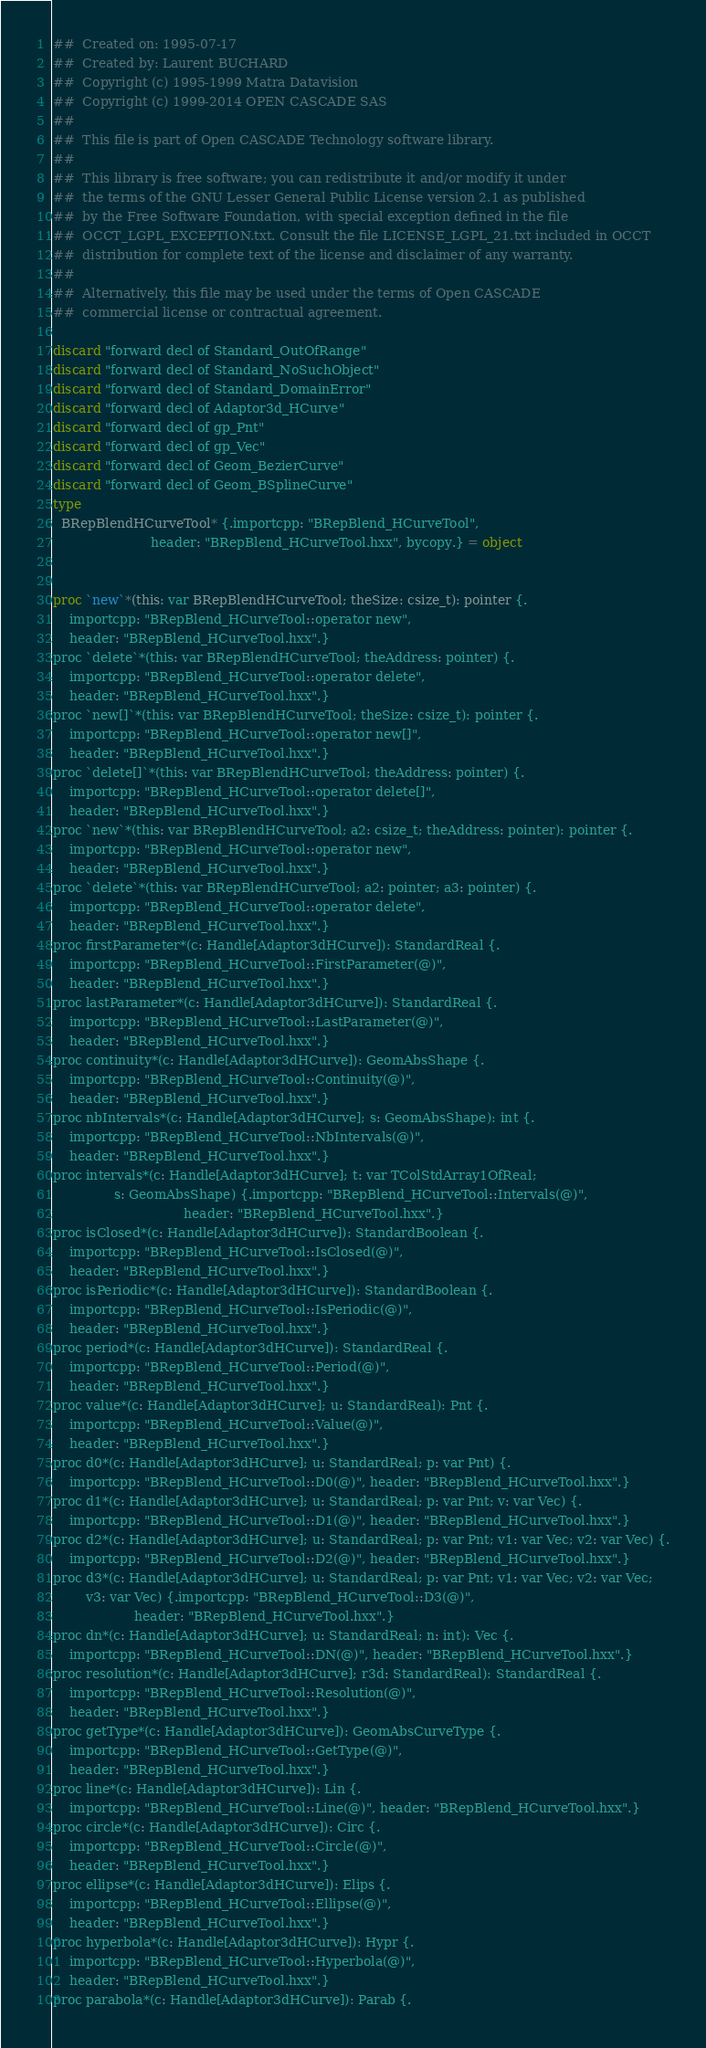<code> <loc_0><loc_0><loc_500><loc_500><_Nim_>##  Created on: 1995-07-17
##  Created by: Laurent BUCHARD
##  Copyright (c) 1995-1999 Matra Datavision
##  Copyright (c) 1999-2014 OPEN CASCADE SAS
##
##  This file is part of Open CASCADE Technology software library.
##
##  This library is free software; you can redistribute it and/or modify it under
##  the terms of the GNU Lesser General Public License version 2.1 as published
##  by the Free Software Foundation, with special exception defined in the file
##  OCCT_LGPL_EXCEPTION.txt. Consult the file LICENSE_LGPL_21.txt included in OCCT
##  distribution for complete text of the license and disclaimer of any warranty.
##
##  Alternatively, this file may be used under the terms of Open CASCADE
##  commercial license or contractual agreement.

discard "forward decl of Standard_OutOfRange"
discard "forward decl of Standard_NoSuchObject"
discard "forward decl of Standard_DomainError"
discard "forward decl of Adaptor3d_HCurve"
discard "forward decl of gp_Pnt"
discard "forward decl of gp_Vec"
discard "forward decl of Geom_BezierCurve"
discard "forward decl of Geom_BSplineCurve"
type
  BRepBlendHCurveTool* {.importcpp: "BRepBlend_HCurveTool",
                        header: "BRepBlend_HCurveTool.hxx", bycopy.} = object


proc `new`*(this: var BRepBlendHCurveTool; theSize: csize_t): pointer {.
    importcpp: "BRepBlend_HCurveTool::operator new",
    header: "BRepBlend_HCurveTool.hxx".}
proc `delete`*(this: var BRepBlendHCurveTool; theAddress: pointer) {.
    importcpp: "BRepBlend_HCurveTool::operator delete",
    header: "BRepBlend_HCurveTool.hxx".}
proc `new[]`*(this: var BRepBlendHCurveTool; theSize: csize_t): pointer {.
    importcpp: "BRepBlend_HCurveTool::operator new[]",
    header: "BRepBlend_HCurveTool.hxx".}
proc `delete[]`*(this: var BRepBlendHCurveTool; theAddress: pointer) {.
    importcpp: "BRepBlend_HCurveTool::operator delete[]",
    header: "BRepBlend_HCurveTool.hxx".}
proc `new`*(this: var BRepBlendHCurveTool; a2: csize_t; theAddress: pointer): pointer {.
    importcpp: "BRepBlend_HCurveTool::operator new",
    header: "BRepBlend_HCurveTool.hxx".}
proc `delete`*(this: var BRepBlendHCurveTool; a2: pointer; a3: pointer) {.
    importcpp: "BRepBlend_HCurveTool::operator delete",
    header: "BRepBlend_HCurveTool.hxx".}
proc firstParameter*(c: Handle[Adaptor3dHCurve]): StandardReal {.
    importcpp: "BRepBlend_HCurveTool::FirstParameter(@)",
    header: "BRepBlend_HCurveTool.hxx".}
proc lastParameter*(c: Handle[Adaptor3dHCurve]): StandardReal {.
    importcpp: "BRepBlend_HCurveTool::LastParameter(@)",
    header: "BRepBlend_HCurveTool.hxx".}
proc continuity*(c: Handle[Adaptor3dHCurve]): GeomAbsShape {.
    importcpp: "BRepBlend_HCurveTool::Continuity(@)",
    header: "BRepBlend_HCurveTool.hxx".}
proc nbIntervals*(c: Handle[Adaptor3dHCurve]; s: GeomAbsShape): int {.
    importcpp: "BRepBlend_HCurveTool::NbIntervals(@)",
    header: "BRepBlend_HCurveTool.hxx".}
proc intervals*(c: Handle[Adaptor3dHCurve]; t: var TColStdArray1OfReal;
               s: GeomAbsShape) {.importcpp: "BRepBlend_HCurveTool::Intervals(@)",
                                header: "BRepBlend_HCurveTool.hxx".}
proc isClosed*(c: Handle[Adaptor3dHCurve]): StandardBoolean {.
    importcpp: "BRepBlend_HCurveTool::IsClosed(@)",
    header: "BRepBlend_HCurveTool.hxx".}
proc isPeriodic*(c: Handle[Adaptor3dHCurve]): StandardBoolean {.
    importcpp: "BRepBlend_HCurveTool::IsPeriodic(@)",
    header: "BRepBlend_HCurveTool.hxx".}
proc period*(c: Handle[Adaptor3dHCurve]): StandardReal {.
    importcpp: "BRepBlend_HCurveTool::Period(@)",
    header: "BRepBlend_HCurveTool.hxx".}
proc value*(c: Handle[Adaptor3dHCurve]; u: StandardReal): Pnt {.
    importcpp: "BRepBlend_HCurveTool::Value(@)",
    header: "BRepBlend_HCurveTool.hxx".}
proc d0*(c: Handle[Adaptor3dHCurve]; u: StandardReal; p: var Pnt) {.
    importcpp: "BRepBlend_HCurveTool::D0(@)", header: "BRepBlend_HCurveTool.hxx".}
proc d1*(c: Handle[Adaptor3dHCurve]; u: StandardReal; p: var Pnt; v: var Vec) {.
    importcpp: "BRepBlend_HCurveTool::D1(@)", header: "BRepBlend_HCurveTool.hxx".}
proc d2*(c: Handle[Adaptor3dHCurve]; u: StandardReal; p: var Pnt; v1: var Vec; v2: var Vec) {.
    importcpp: "BRepBlend_HCurveTool::D2(@)", header: "BRepBlend_HCurveTool.hxx".}
proc d3*(c: Handle[Adaptor3dHCurve]; u: StandardReal; p: var Pnt; v1: var Vec; v2: var Vec;
        v3: var Vec) {.importcpp: "BRepBlend_HCurveTool::D3(@)",
                    header: "BRepBlend_HCurveTool.hxx".}
proc dn*(c: Handle[Adaptor3dHCurve]; u: StandardReal; n: int): Vec {.
    importcpp: "BRepBlend_HCurveTool::DN(@)", header: "BRepBlend_HCurveTool.hxx".}
proc resolution*(c: Handle[Adaptor3dHCurve]; r3d: StandardReal): StandardReal {.
    importcpp: "BRepBlend_HCurveTool::Resolution(@)",
    header: "BRepBlend_HCurveTool.hxx".}
proc getType*(c: Handle[Adaptor3dHCurve]): GeomAbsCurveType {.
    importcpp: "BRepBlend_HCurveTool::GetType(@)",
    header: "BRepBlend_HCurveTool.hxx".}
proc line*(c: Handle[Adaptor3dHCurve]): Lin {.
    importcpp: "BRepBlend_HCurveTool::Line(@)", header: "BRepBlend_HCurveTool.hxx".}
proc circle*(c: Handle[Adaptor3dHCurve]): Circ {.
    importcpp: "BRepBlend_HCurveTool::Circle(@)",
    header: "BRepBlend_HCurveTool.hxx".}
proc ellipse*(c: Handle[Adaptor3dHCurve]): Elips {.
    importcpp: "BRepBlend_HCurveTool::Ellipse(@)",
    header: "BRepBlend_HCurveTool.hxx".}
proc hyperbola*(c: Handle[Adaptor3dHCurve]): Hypr {.
    importcpp: "BRepBlend_HCurveTool::Hyperbola(@)",
    header: "BRepBlend_HCurveTool.hxx".}
proc parabola*(c: Handle[Adaptor3dHCurve]): Parab {.</code> 